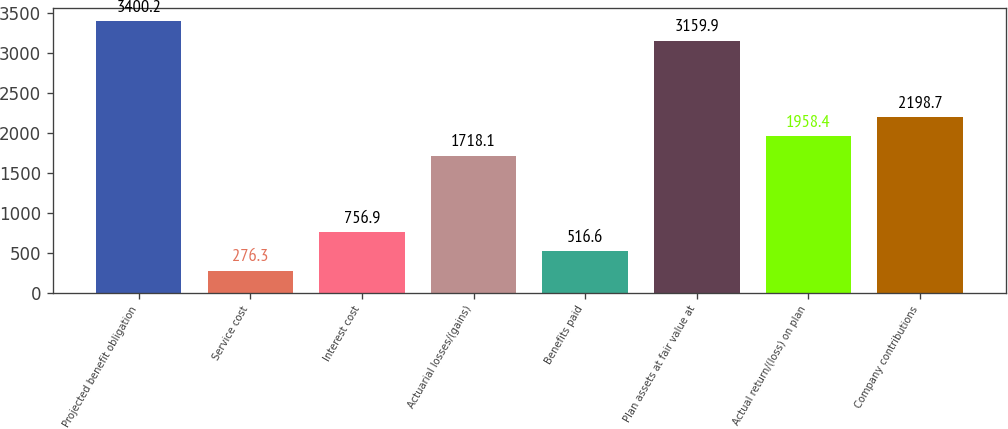Convert chart. <chart><loc_0><loc_0><loc_500><loc_500><bar_chart><fcel>Projected benefit obligation<fcel>Service cost<fcel>Interest cost<fcel>Actuarial losses/(gains)<fcel>Benefits paid<fcel>Plan assets at fair value at<fcel>Actual return/(loss) on plan<fcel>Company contributions<nl><fcel>3400.2<fcel>276.3<fcel>756.9<fcel>1718.1<fcel>516.6<fcel>3159.9<fcel>1958.4<fcel>2198.7<nl></chart> 